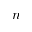<formula> <loc_0><loc_0><loc_500><loc_500>n</formula> 